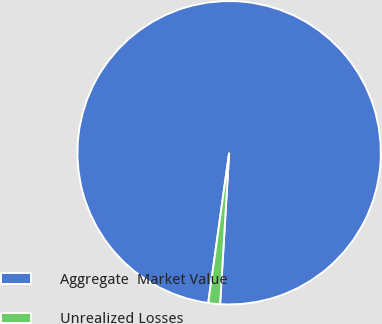Convert chart to OTSL. <chart><loc_0><loc_0><loc_500><loc_500><pie_chart><fcel>Aggregate  Market Value<fcel>Unrealized Losses<nl><fcel>98.75%<fcel>1.25%<nl></chart> 